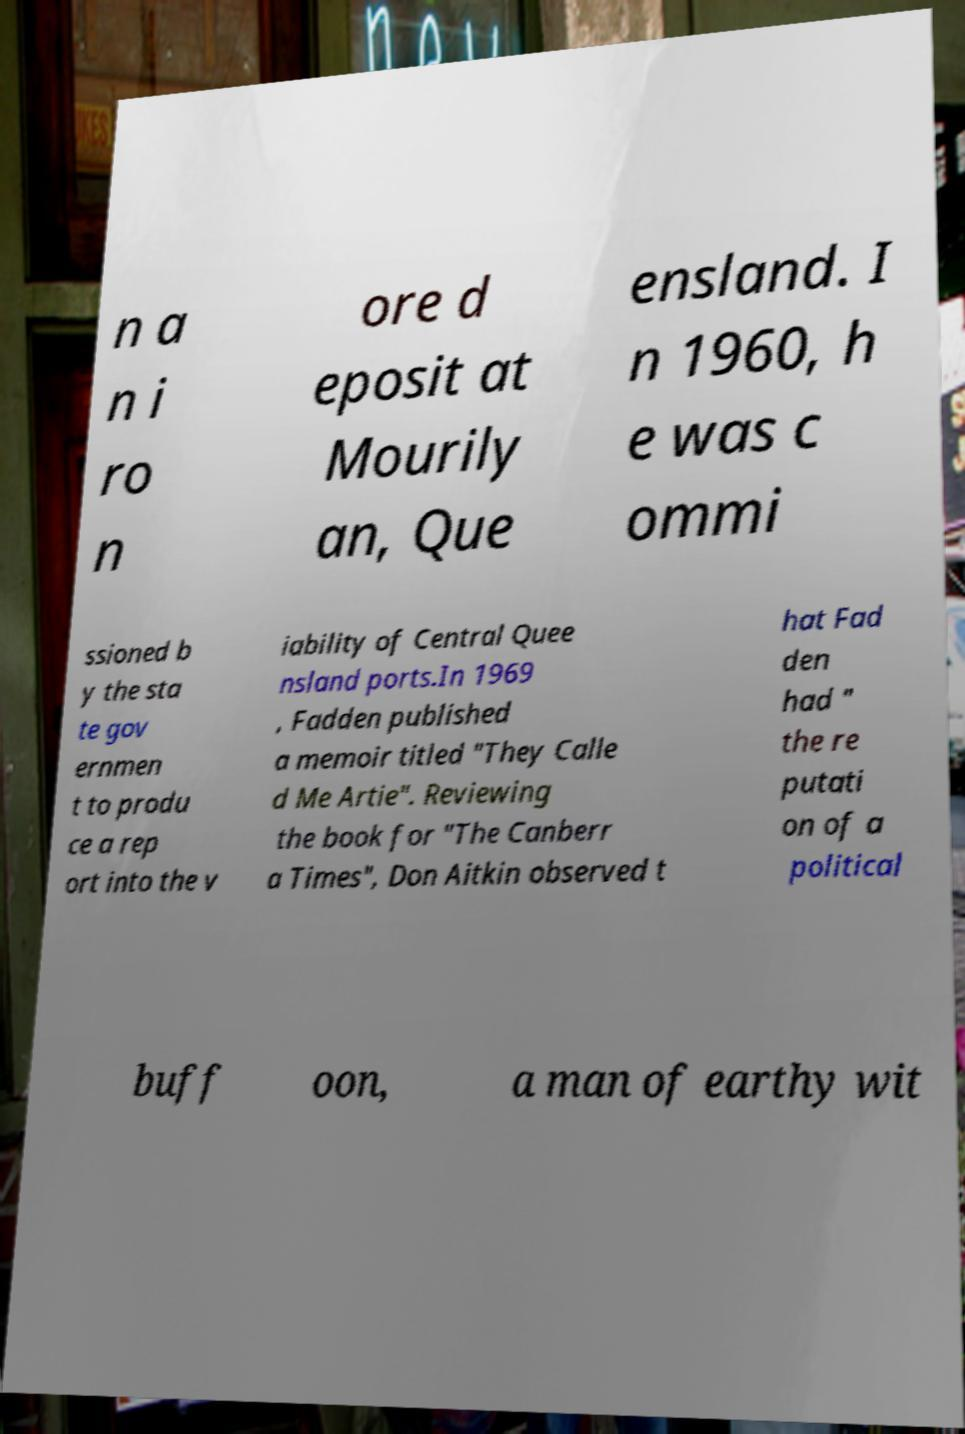Could you assist in decoding the text presented in this image and type it out clearly? n a n i ro n ore d eposit at Mourily an, Que ensland. I n 1960, h e was c ommi ssioned b y the sta te gov ernmen t to produ ce a rep ort into the v iability of Central Quee nsland ports.In 1969 , Fadden published a memoir titled "They Calle d Me Artie". Reviewing the book for "The Canberr a Times", Don Aitkin observed t hat Fad den had " the re putati on of a political buff oon, a man of earthy wit 